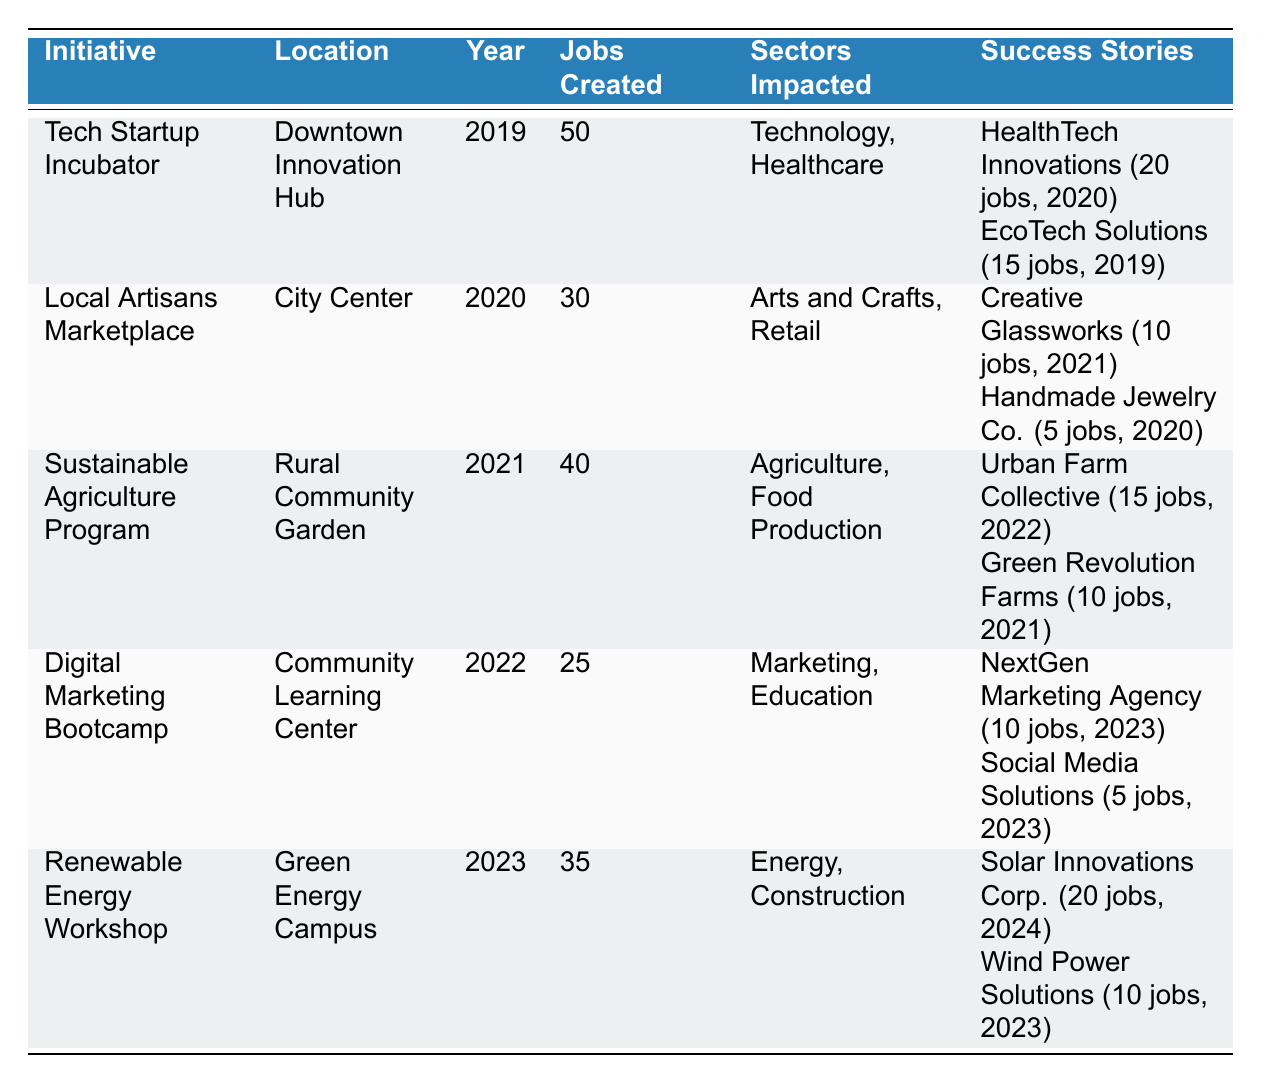What initiative created the most jobs? By looking at the "Jobs Created" column, we see that the "Tech Startup Incubator" has the highest number of jobs created at 50.
Answer: Tech Startup Incubator Which sector was impacted the most by the "Digital Marketing Bootcamp"? The "Digital Marketing Bootcamp" impacted both "Marketing" and "Education" sectors as per the "Sectors Impacted" column.
Answer: Marketing, Education How many total jobs were created by initiatives in 2021? In 2021, two initiatives were present: the "Sustainable Agriculture Program" with 40 jobs and the "Digital Marketing Bootcamp" which is in 2022. Therefore, only the "Sustainable Agriculture Program" contributes, with 40 jobs created.
Answer: 40 Did the "Renewable Energy Workshop" have more jobs created than the "Local Artisans Marketplace"? The "Renewable Energy Workshop" created 35 jobs, while the "Local Artisans Marketplace" created 30 jobs, so yes, it did have more jobs created.
Answer: Yes What is the total funding amount for all initiatives in 2020 and 2021? The "Local Artisans Marketplace" in 2020 had a funding amount of 80,000 and the "Sustainable Agriculture Program" in 2021 had 120,000. The total is 80,000 + 120,000 = 200,000.
Answer: 200,000 How many total jobs were created by the success stories of the "Tech Startup Incubator"? The success stories are "HealthTech Innovations" with 20 jobs and "EcoTech Solutions" with 15 jobs. Summing these gives 20 + 15 = 35.
Answer: 35 Is it true that all initiatives except the "Renewable Energy Workshop" were established before 2023? Checking the years listed, the "Renewable Energy Workshop" is the only initiative from 2023. All others (2019, 2020, 2021, 2022) were established prior, confirming that it is true.
Answer: True Which initiative had the highest funding amount in 2023? Looking at the "Funding Amount" column, the "Renewable Energy Workshop" has the highest funding of 200,000 dollars compared to others listed for different years.
Answer: 200,000 